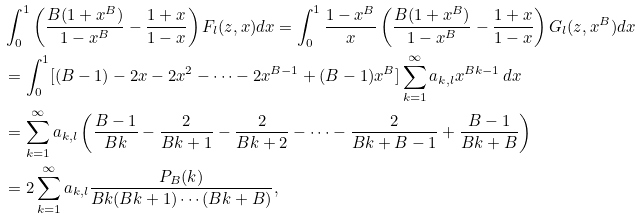<formula> <loc_0><loc_0><loc_500><loc_500>& \int _ { 0 } ^ { 1 } \left ( \frac { B ( 1 + x ^ { B } ) } { 1 - x ^ { B } } - \frac { 1 + x } { 1 - x } \right ) F _ { l } ( z , x ) d x = \int _ { 0 } ^ { 1 } \frac { 1 - x ^ { B } } { x } \left ( \frac { B ( 1 + x ^ { B } ) } { 1 - x ^ { B } } - \frac { 1 + x } { 1 - x } \right ) G _ { l } ( z , x ^ { B } ) d x \\ & = \int _ { 0 } ^ { 1 } [ ( B - 1 ) - 2 x - 2 x ^ { 2 } - \cdots - 2 x ^ { B - 1 } + ( B - 1 ) x ^ { B } ] \sum _ { k = 1 } ^ { \infty } a _ { k , l } x ^ { B k - 1 } \, d x \\ & = \sum _ { k = 1 } ^ { \infty } a _ { k , l } \left ( \frac { B - 1 } { B k } - \frac { 2 } { B k + 1 } - \frac { 2 } { B k + 2 } - \cdots - \frac { 2 } { B k + B - 1 } + \frac { B - 1 } { B k + B } \right ) \\ & = 2 \sum _ { k = 1 } ^ { \infty } a _ { k , l } \frac { P _ { B } ( k ) } { B k ( B k + 1 ) \cdots ( B k + B ) } ,</formula> 